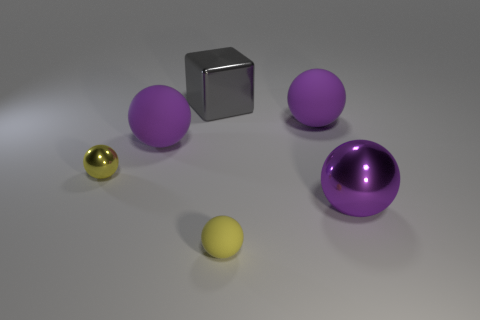What number of purple spheres are behind the tiny yellow metallic thing and right of the small rubber object? 1 